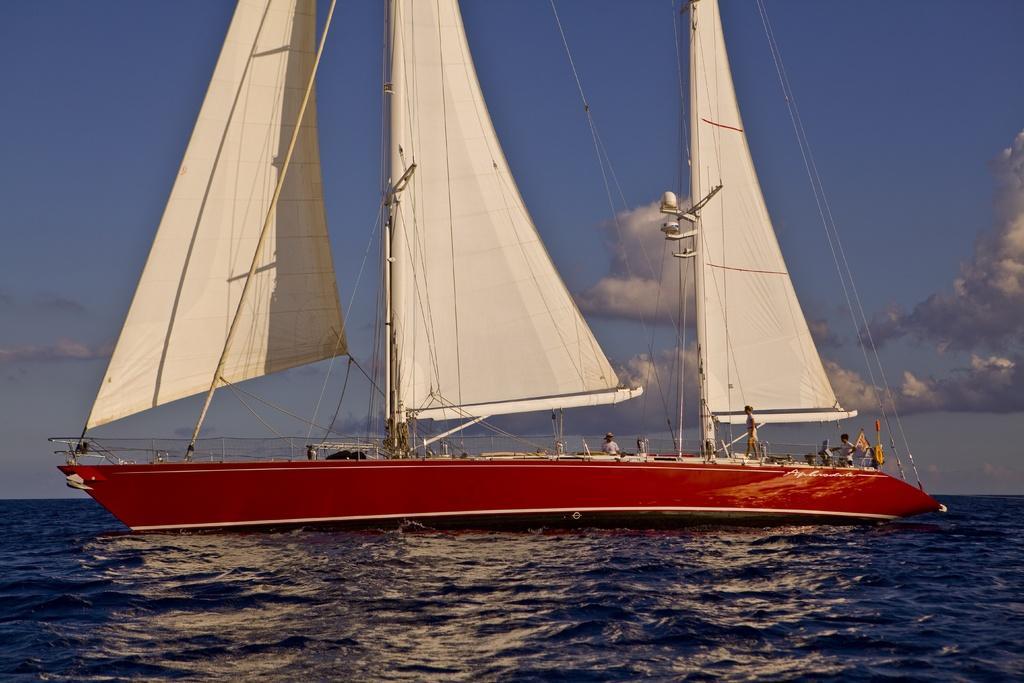Could you give a brief overview of what you see in this image? In the picture we can see a boat which is red in color in the water and on the boat we can see some poles with curtains fixed it with wires and in the background we can see a sky with clouds. 